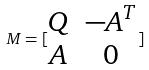Convert formula to latex. <formula><loc_0><loc_0><loc_500><loc_500>M = [ \begin{matrix} Q & - A ^ { T } \\ A & 0 \end{matrix} ]</formula> 